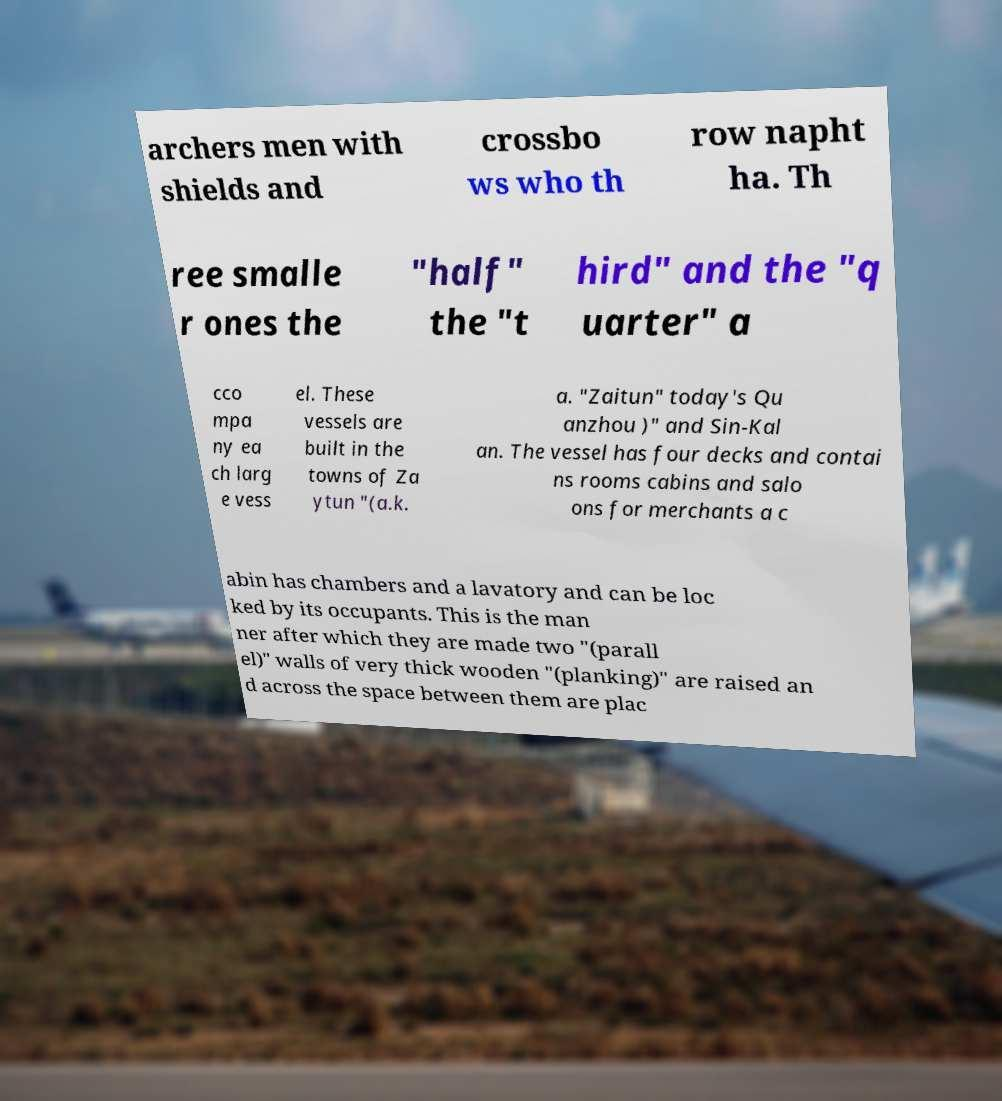There's text embedded in this image that I need extracted. Can you transcribe it verbatim? archers men with shields and crossbo ws who th row napht ha. Th ree smalle r ones the "half" the "t hird" and the "q uarter" a cco mpa ny ea ch larg e vess el. These vessels are built in the towns of Za ytun "(a.k. a. "Zaitun" today's Qu anzhou )" and Sin-Kal an. The vessel has four decks and contai ns rooms cabins and salo ons for merchants a c abin has chambers and a lavatory and can be loc ked by its occupants. This is the man ner after which they are made two "(parall el)" walls of very thick wooden "(planking)" are raised an d across the space between them are plac 